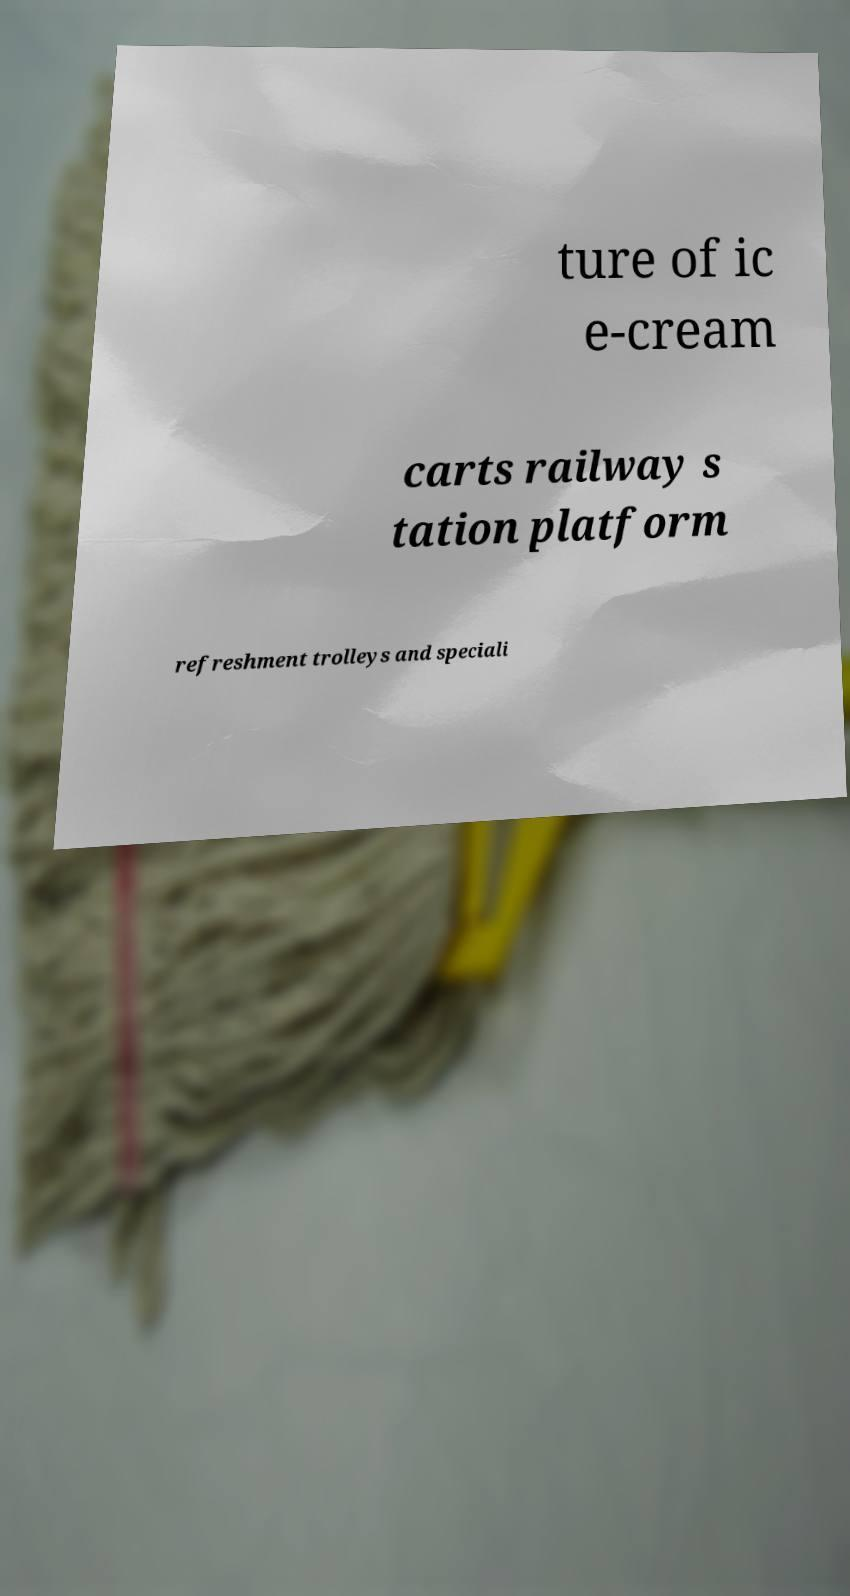For documentation purposes, I need the text within this image transcribed. Could you provide that? ture of ic e-cream carts railway s tation platform refreshment trolleys and speciali 